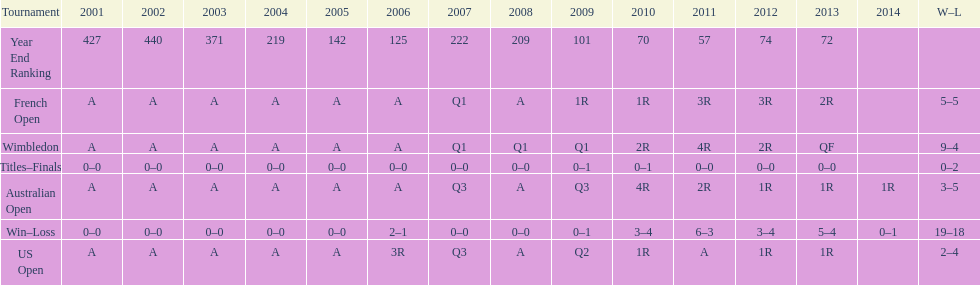What was the total number of matches played from 2001 to 2014? 37. 